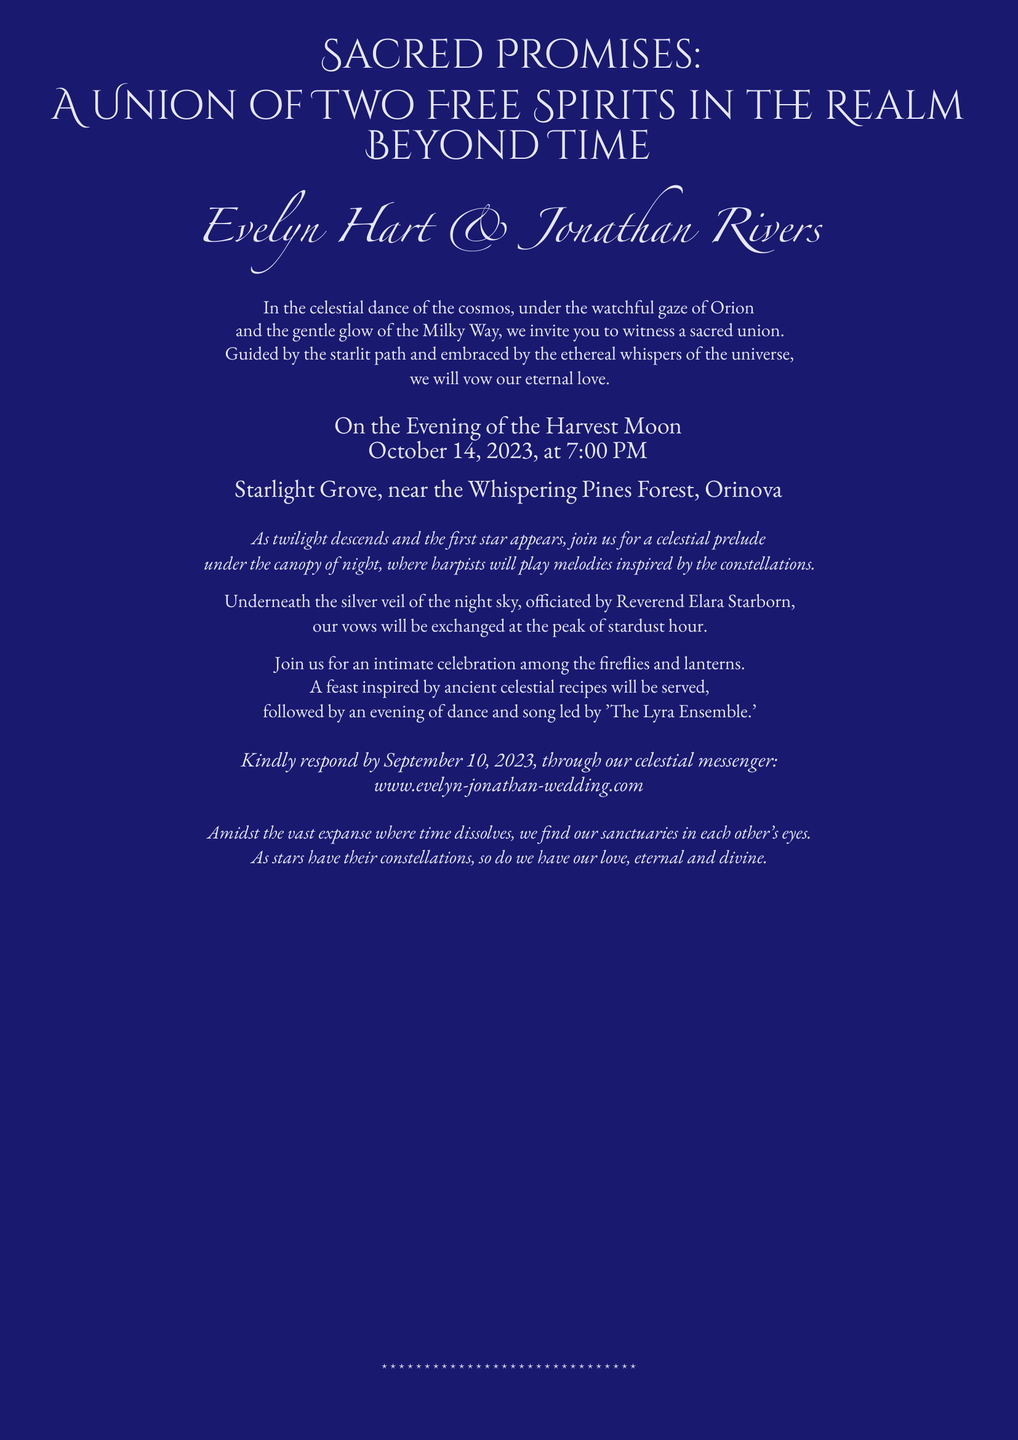What are the names of the couple? The document states the names of the couple as Evelyn Hart and Jonathan Rivers.
Answer: Evelyn Hart & Jonathan Rivers What date is the wedding taking place? The wedding date is explicitly mentioned in the invitation as October 14, 2023.
Answer: October 14, 2023 What time is the wedding ceremony scheduled for? The time of the ceremony is specified in the document as 7:00 PM.
Answer: 7:00 PM Where is the wedding venue located? The document indicates the venue as Starlight Grove, near the Whispering Pines Forest, Orinova.
Answer: Starlight Grove, near the Whispering Pines Forest, Orinova Who will officiate the ceremony? The officiant of the ceremony is mentioned in the document as Reverend Elara Starborn.
Answer: Reverend Elara Starborn What type of music will be played during the celebration? The document mentions that melodies inspired by the constellations will be played by harpists.
Answer: Melodies inspired by the constellations What should guests respond by and how? Guests are asked to respond by September 10, 2023, through a specified website.
Answer: September 10, 2023, through www.evelyn-jonathan-wedding.com What is the theme of the wedding invitation? The theme of the wedding invitation is indicated by the title "Sacred Promises: A Union of Two Free Spirits in the Realm Beyond Time".
Answer: Sacred Promises: A Union of Two Free Spirits in the Realm Beyond Time What kind of celebration will follow the ceremony? The document describes the celebration as an intimate gathering among fireflies and lanterns.
Answer: An intimate celebration among the fireflies and lanterns 